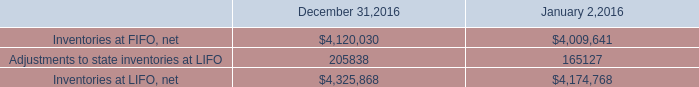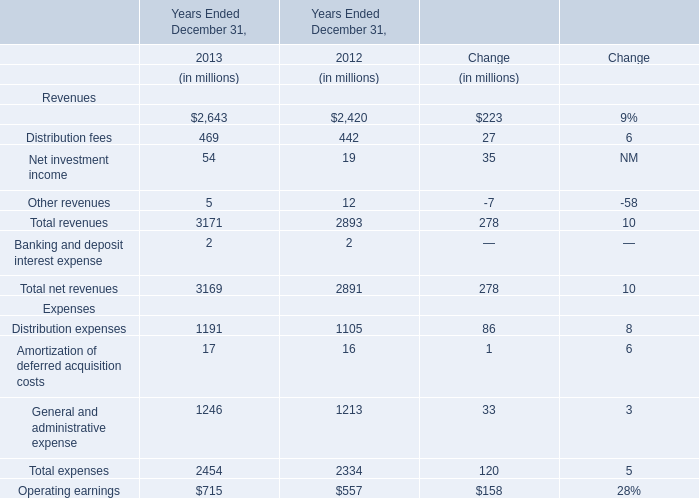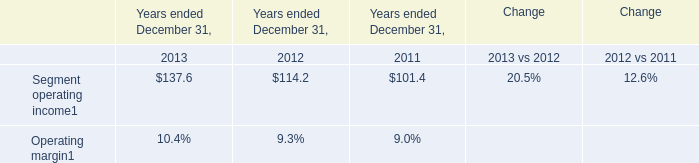In the year with the most Distribution fees in table 1, what is the growth rate of Management and financial advice fees in table 1? 
Computations: ((2643 - 2420) / 2420)
Answer: 0.09215. 